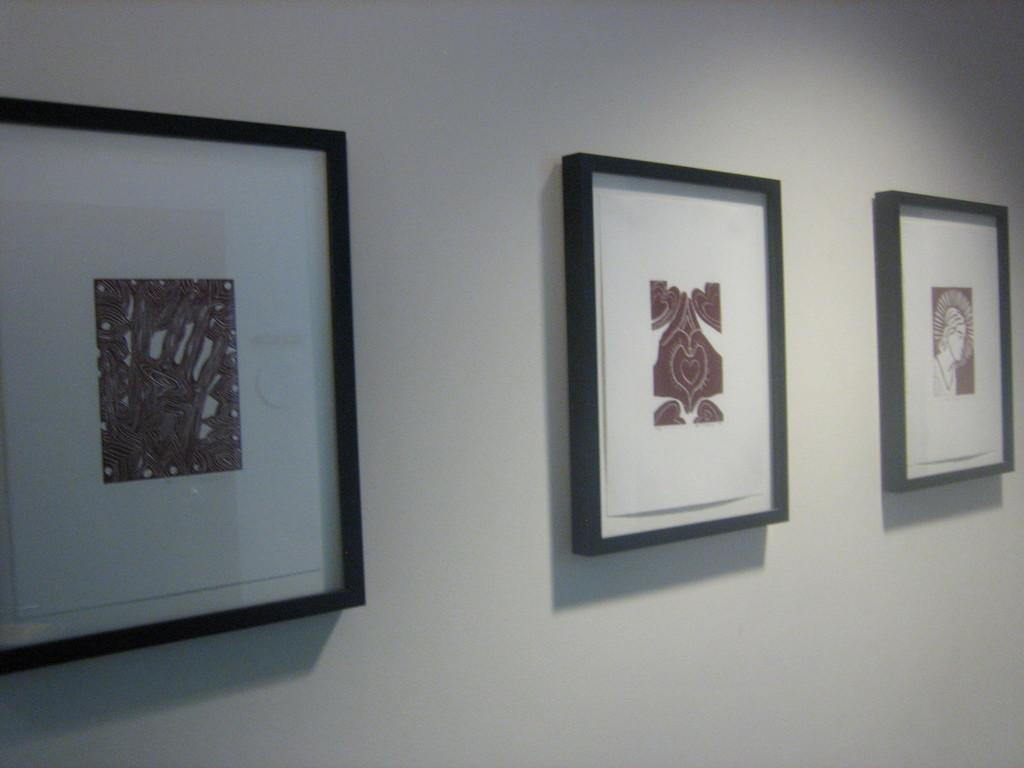What can be seen in the image that is attached to a wall? There are frames in the image that are attached to a wall. What is the color of the wall in the image? The wall in the image is painted white. How much debt does the daughter owe to the manager in the image? There is no mention of debt, a daughter, or a manager in the image. 